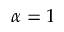Convert formula to latex. <formula><loc_0><loc_0><loc_500><loc_500>\alpha = 1</formula> 